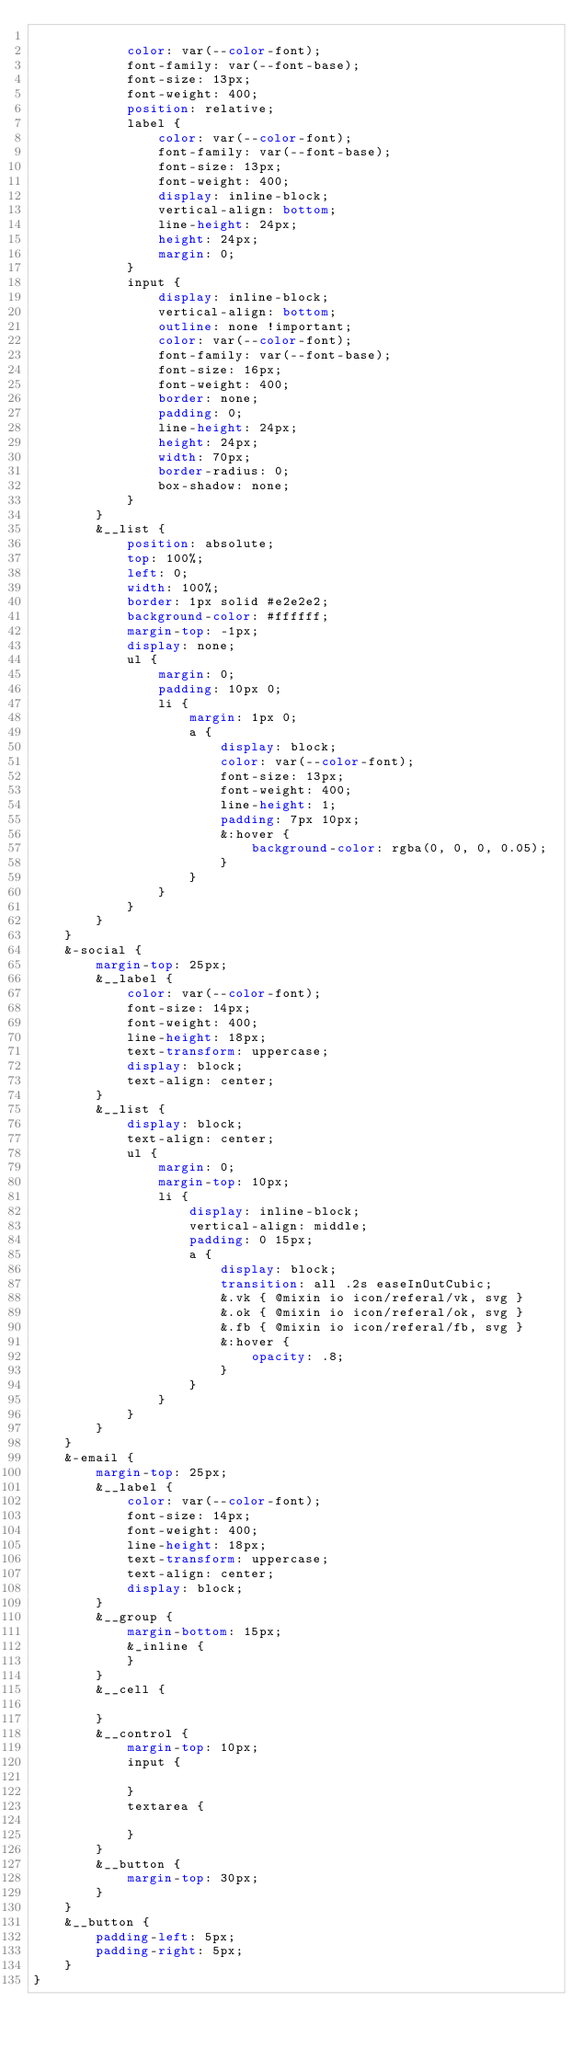Convert code to text. <code><loc_0><loc_0><loc_500><loc_500><_CSS_>
            color: var(--color-font);
            font-family: var(--font-base);
            font-size: 13px;
            font-weight: 400;
            position: relative;
            label {
                color: var(--color-font);
                font-family: var(--font-base);
                font-size: 13px;
                font-weight: 400;
                display: inline-block;
                vertical-align: bottom;
                line-height: 24px;
                height: 24px;
                margin: 0;
            }
            input {
                display: inline-block;
                vertical-align: bottom;
                outline: none !important;
                color: var(--color-font);
                font-family: var(--font-base);
                font-size: 16px;
                font-weight: 400;
                border: none;
                padding: 0;
                line-height: 24px;
                height: 24px;
                width: 70px;
                border-radius: 0;
                box-shadow: none;
            }
        }
        &__list {
            position: absolute;
            top: 100%;
            left: 0;
            width: 100%;
            border: 1px solid #e2e2e2;
            background-color: #ffffff;
            margin-top: -1px;
            display: none;
            ul {
                margin: 0;
                padding: 10px 0;
                li {
                    margin: 1px 0;
                    a {
                        display: block;
                        color: var(--color-font);
                        font-size: 13px;
                        font-weight: 400;
                        line-height: 1;
                        padding: 7px 10px;
                        &:hover {
                            background-color: rgba(0, 0, 0, 0.05);
                        }
                    }
                }
            }
        }
    }
    &-social {
        margin-top: 25px;
        &__label {
            color: var(--color-font);
            font-size: 14px;
            font-weight: 400;
            line-height: 18px;
            text-transform: uppercase;
            display: block;
            text-align: center;
        }
        &__list {
            display: block;
            text-align: center;
            ul {
                margin: 0;
                margin-top: 10px;
                li {
                    display: inline-block;
                    vertical-align: middle;
                    padding: 0 15px;
                    a {
                        display: block;
                        transition: all .2s easeInOutCubic;
                        &.vk { @mixin io icon/referal/vk, svg }
                        &.ok { @mixin io icon/referal/ok, svg }
                        &.fb { @mixin io icon/referal/fb, svg }
                        &:hover {
                            opacity: .8;
                        }
                    }
                }
            }
        }
    }
    &-email {
        margin-top: 25px;
        &__label {
            color: var(--color-font);
            font-size: 14px;
            font-weight: 400;
            line-height: 18px;
            text-transform: uppercase;
            text-align: center;
            display: block;
        }
        &__group {
            margin-bottom: 15px;
            &_inline {
            }
        }
        &__cell {

        }
        &__control {
            margin-top: 10px;
            input {

            }
            textarea {

            }
        }
        &__button {
            margin-top: 30px;
        }
    }
    &__button {
        padding-left: 5px;
        padding-right: 5px;
    }
}</code> 